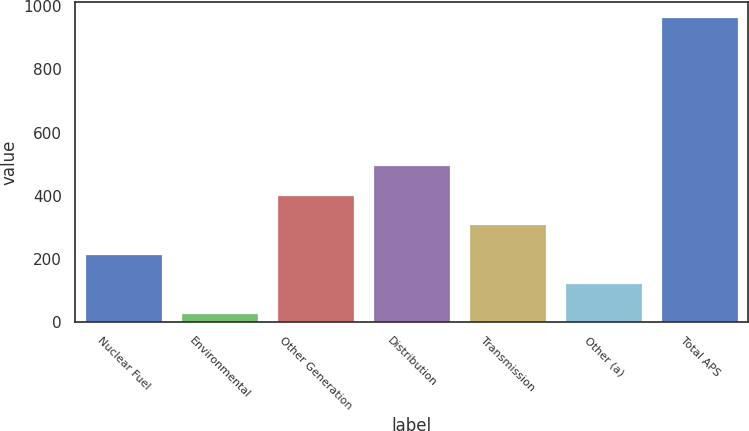Convert chart to OTSL. <chart><loc_0><loc_0><loc_500><loc_500><bar_chart><fcel>Nuclear Fuel<fcel>Environmental<fcel>Other Generation<fcel>Distribution<fcel>Transmission<fcel>Other (a)<fcel>Total APS<nl><fcel>217<fcel>30<fcel>404<fcel>497.5<fcel>310.5<fcel>123.5<fcel>965<nl></chart> 